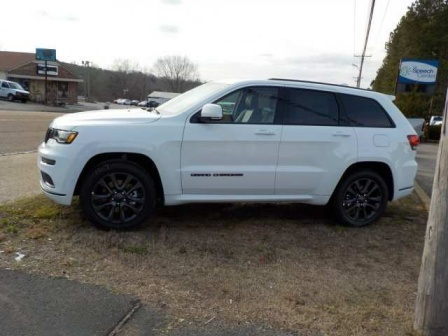Pretend this scene is part of a futuristic world. What technological advancements do you see or imagine? In a futuristic world, this scene might include a high-tech version of the Jeep Grand Cherokee, featuring autonomous driving capabilities, advanced solar panels integrated into the roof for sustainable energy, and augmented reality windows providing navigation and environmental information. The blue sign could display dynamic digital information, and the building might be a multi-functional hub with drone delivery services, automated service kiosks, and holographic advertisements. The environment might also be equipped with smart sensors monitoring air quality and communicating with the vehicles for optimized routes.  Can you describe a realistic day here in both a short summary and a long scenario? Short Summary: On a calm weekday morning, a white Jeep Grand Cherokee is parked as its owner visits the nearby coffee shop, preparing for a day of remote work in the serene, quiet suburban area. Long Scenario: It's a chilly morning in early spring. The white Jeep Grand Cherokee pulls off the road onto a grassy patch, the driver carefully parking next to a quaint coffee shop. The shop, a local favorite with a brown roof and rustic charm, begins to fill with the aroma of fresh-brewed coffee. The driver, Sophia, steps out, embracing the crisp air as she heads inside for her morning ritual: a hot latte and a freshly baked croissant. Sophia finds a cozy corner by the window overlooking her vehicle and the road ahead. She sets up her laptop, ready to tackle the day's tasks remotely. The peaceful setting fuels her productivity, and as the day progresses, she takes short breaks to step outside, visit the blue sign displaying local community events, and enjoy the tranquility of the surrounding area. The day ends with Sophia feeling accomplished and rejuvenated by the serene environment. 